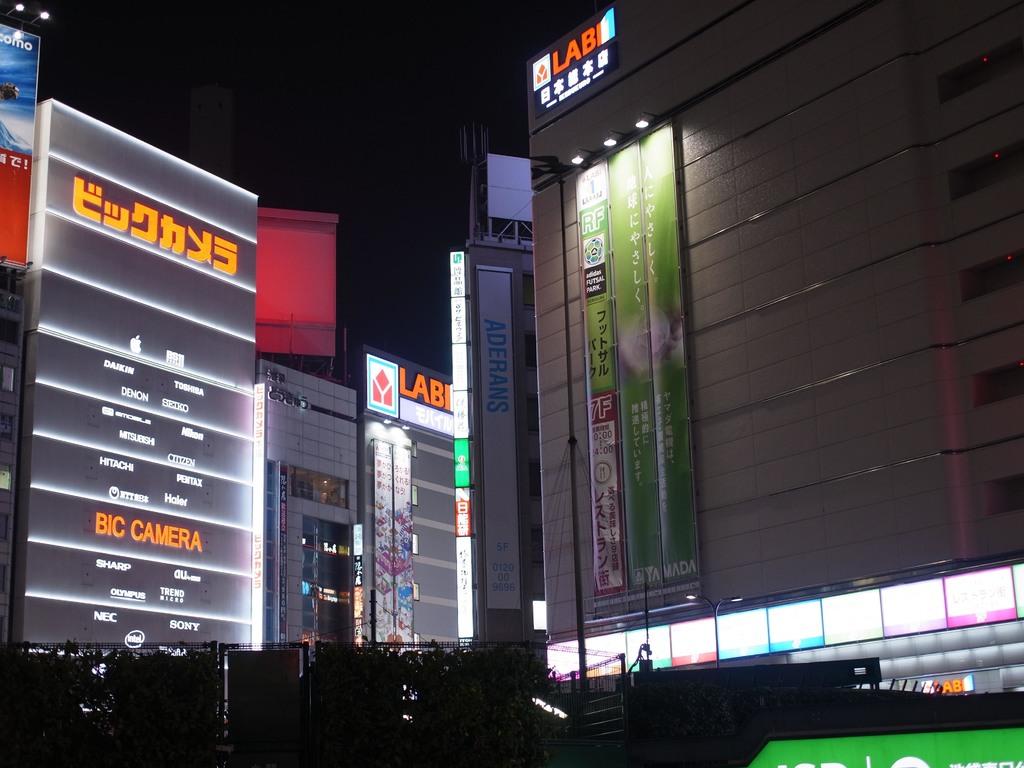What kind of camera is written in orange?
Your answer should be compact. Bic. What is in orange letters on the building to the right?
Provide a succinct answer. Lab. 